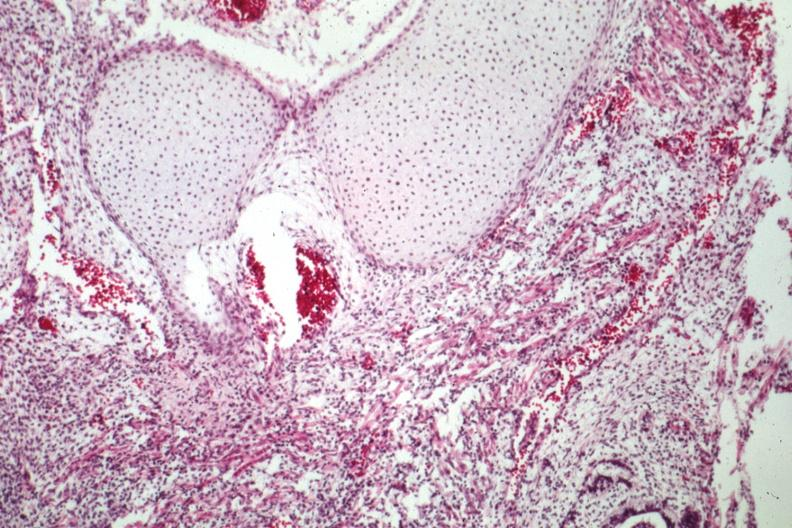what is present?
Answer the question using a single word or phrase. Sacrococcygeal teratoma 